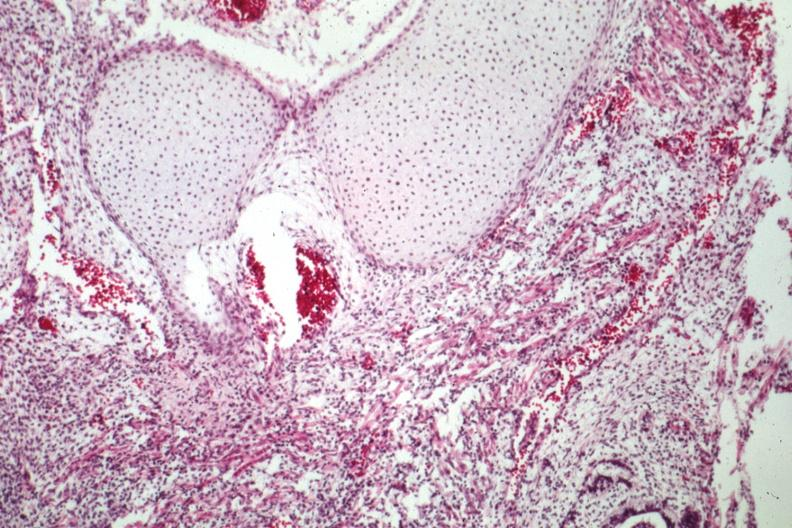what is present?
Answer the question using a single word or phrase. Sacrococcygeal teratoma 